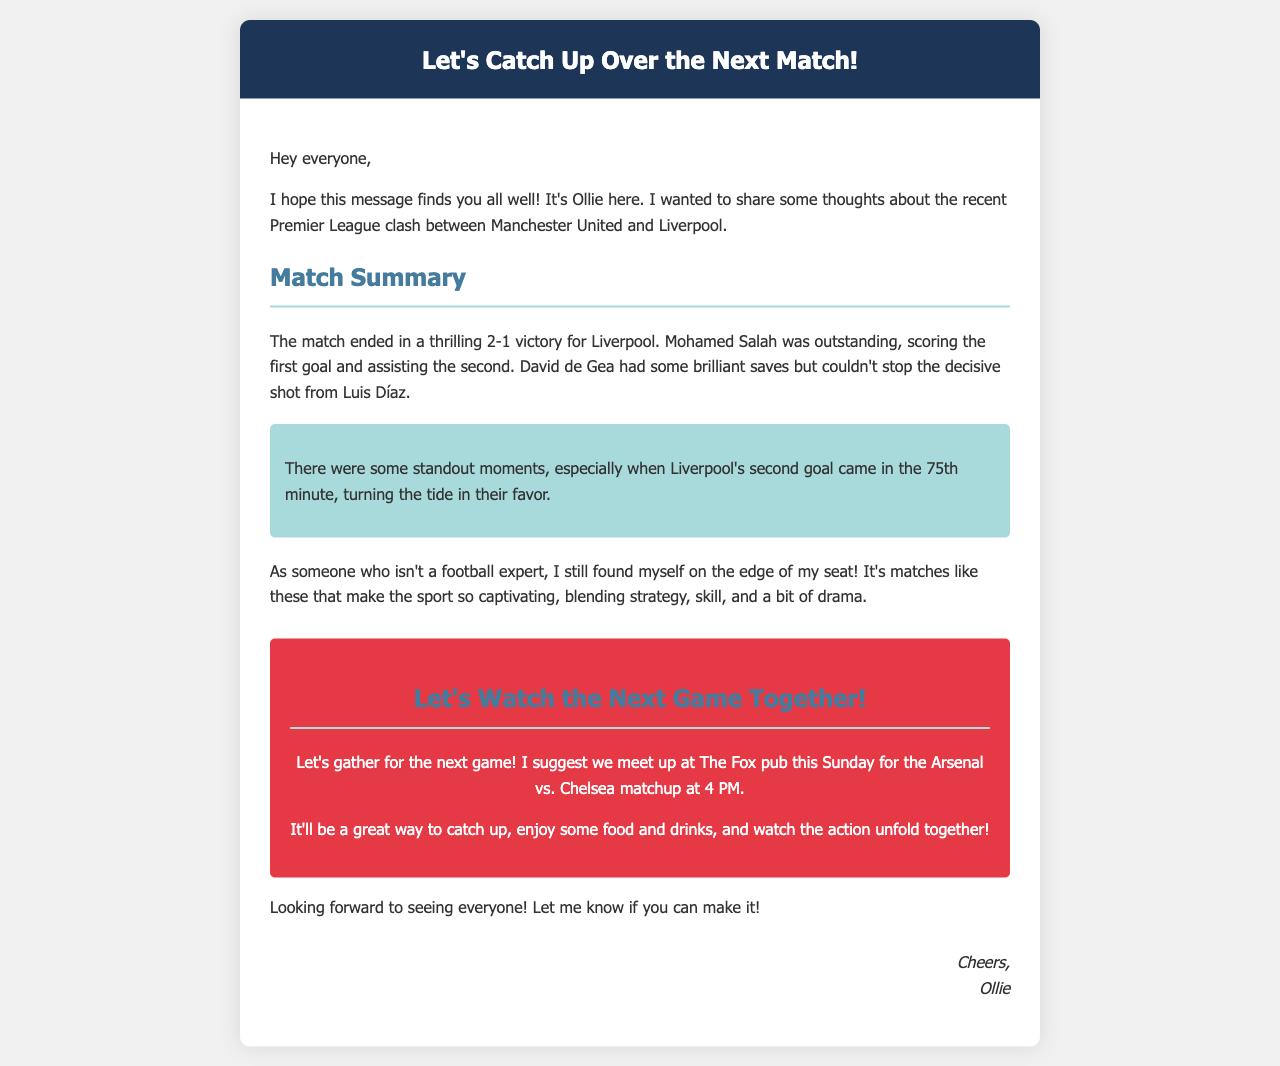What teams played in the recent match? The document mentions Manchester United and Liverpool as the teams that played.
Answer: Manchester United and Liverpool What was the score of the match? The score stated in the document is a 2-1 victory for Liverpool.
Answer: 2-1 Who scored the first goal in the match? The document states that Mohamed Salah scored the first goal of the match.
Answer: Mohamed Salah Where is the suggested meetup location? The document specifies The Fox pub as the location for the meetup.
Answer: The Fox pub What time is the next game scheduled for? The document mentions the next game is scheduled for 4 PM.
Answer: 4 PM What day is the next game? The document indicates that the next game is this Sunday.
Answer: Sunday How did Ollie feel about the match? Ollie expresses that he was on the edge of his seat, indicating he found the match exciting.
Answer: Exciting What was a standout moment in the match? The document highlights the second goal by Liverpool in the 75th minute as a standout moment.
Answer: 75th minute What is the purpose of Ollie's message? The document is intended to share thoughts on a football match and encourage a get-together.
Answer: To share thoughts and encourage a get-together 